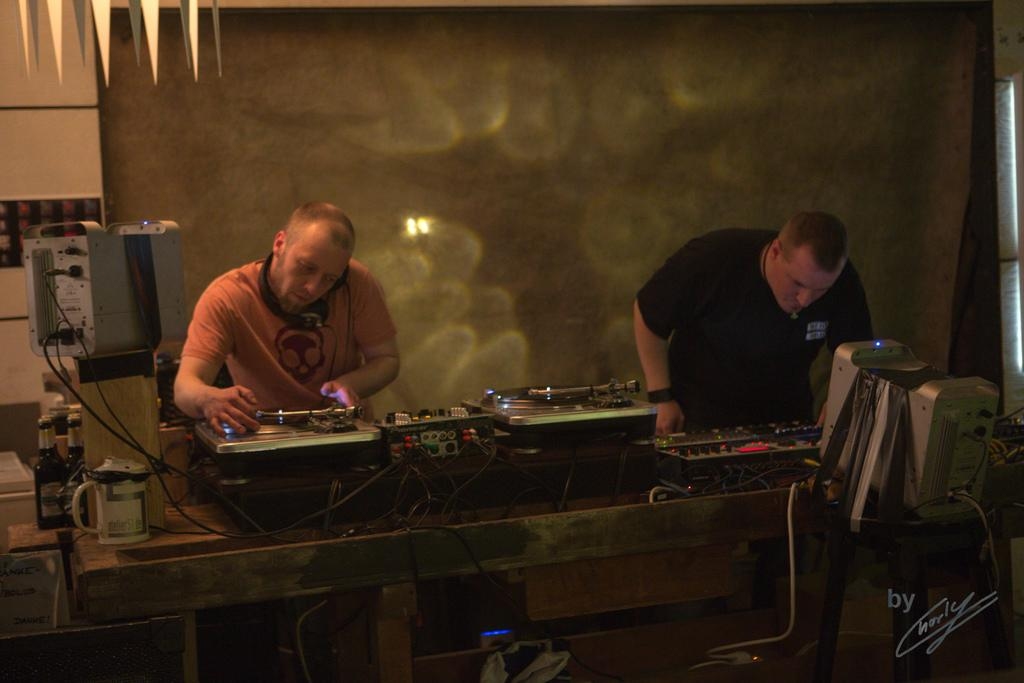What is the person in the image wearing on their head? The person in the image is wearing a headset. Can you describe the other person in the image? There is another person standing in the image. What objects can be seen on the table in the image? There are devices on a table in the image. Is there any text or logo visible in the image? Yes, there is a watermark in the bottom right corner of the image. How many screws can be seen on the person wearing the headset in the image? There are no screws visible on the person wearing the headset in the image. What type of ant is crawling on the table in the image? There are no ants present in the image; it only features devices on the table. 